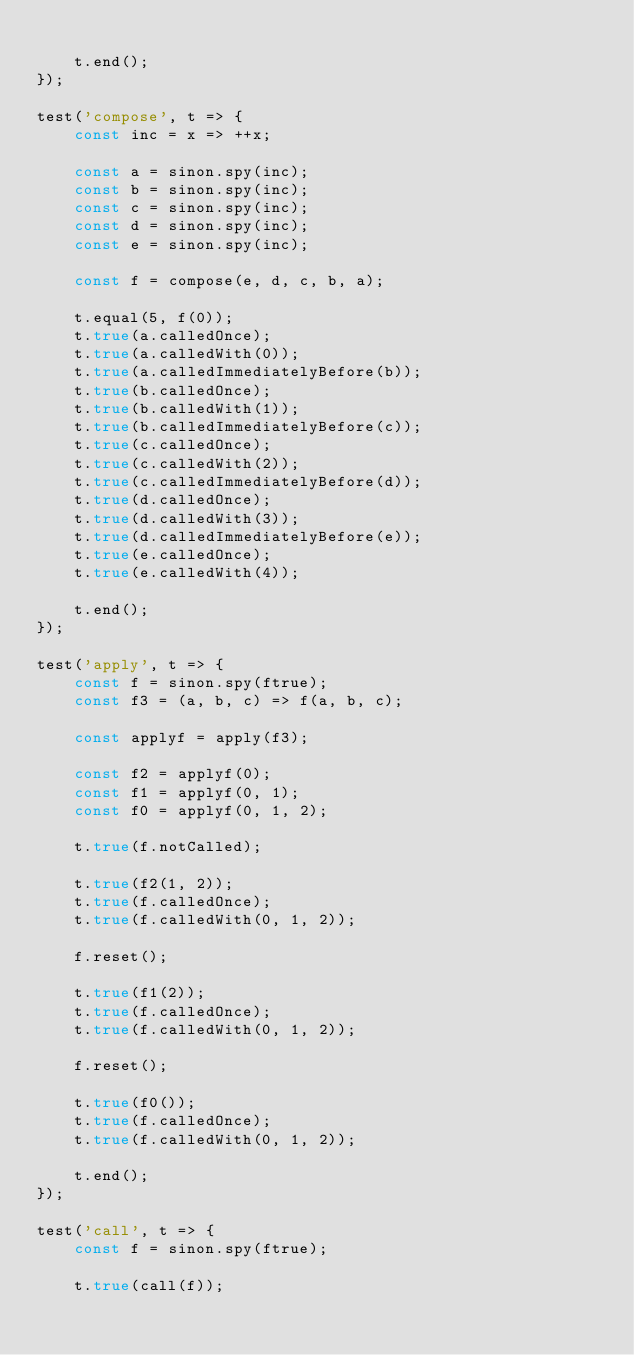<code> <loc_0><loc_0><loc_500><loc_500><_JavaScript_>
    t.end();
});

test('compose', t => {
    const inc = x => ++x;

    const a = sinon.spy(inc);
    const b = sinon.spy(inc);
    const c = sinon.spy(inc);
    const d = sinon.spy(inc);
    const e = sinon.spy(inc);

    const f = compose(e, d, c, b, a);

    t.equal(5, f(0));
    t.true(a.calledOnce);
    t.true(a.calledWith(0));
    t.true(a.calledImmediatelyBefore(b));
    t.true(b.calledOnce);
    t.true(b.calledWith(1));
    t.true(b.calledImmediatelyBefore(c));
    t.true(c.calledOnce);
    t.true(c.calledWith(2));
    t.true(c.calledImmediatelyBefore(d));
    t.true(d.calledOnce);
    t.true(d.calledWith(3));
    t.true(d.calledImmediatelyBefore(e));
    t.true(e.calledOnce);
    t.true(e.calledWith(4));

    t.end();
});

test('apply', t => {
    const f = sinon.spy(ftrue);
    const f3 = (a, b, c) => f(a, b, c);

    const applyf = apply(f3);

    const f2 = applyf(0);
    const f1 = applyf(0, 1);
    const f0 = applyf(0, 1, 2);

    t.true(f.notCalled);

    t.true(f2(1, 2));
    t.true(f.calledOnce);
    t.true(f.calledWith(0, 1, 2));

    f.reset();

    t.true(f1(2));
    t.true(f.calledOnce);
    t.true(f.calledWith(0, 1, 2));

    f.reset();

    t.true(f0());
    t.true(f.calledOnce);
    t.true(f.calledWith(0, 1, 2));

    t.end();
});

test('call', t => {
    const f = sinon.spy(ftrue);

    t.true(call(f));</code> 